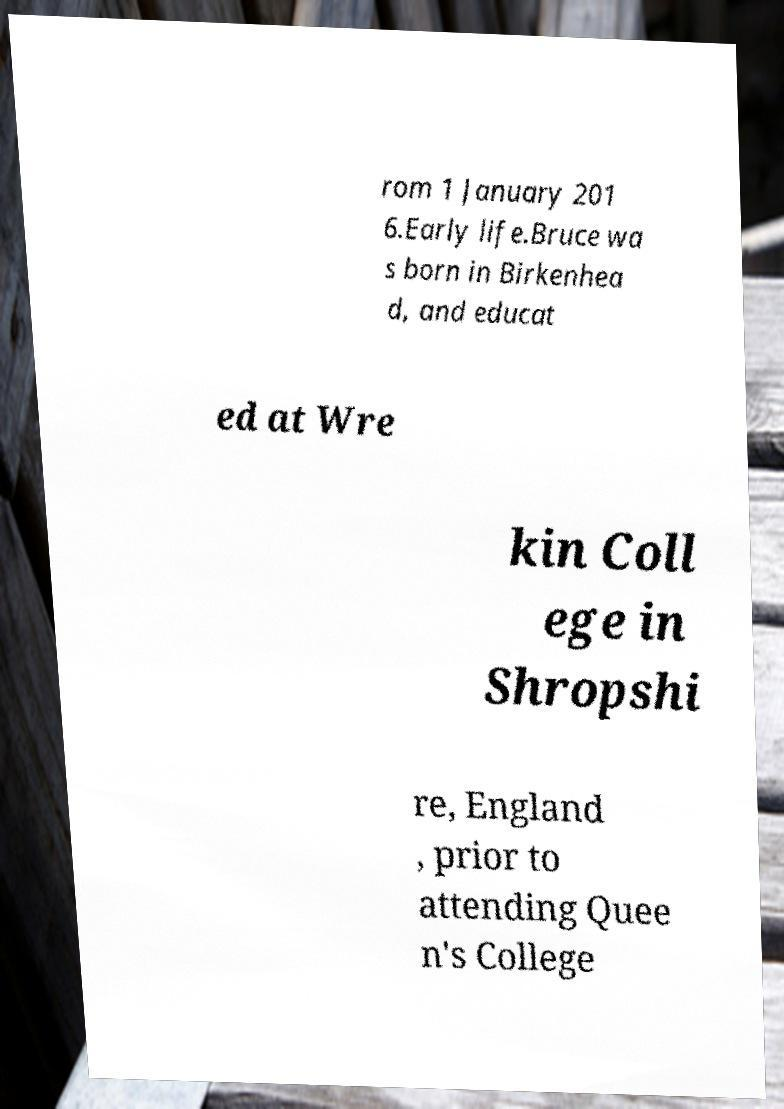There's text embedded in this image that I need extracted. Can you transcribe it verbatim? rom 1 January 201 6.Early life.Bruce wa s born in Birkenhea d, and educat ed at Wre kin Coll ege in Shropshi re, England , prior to attending Quee n's College 